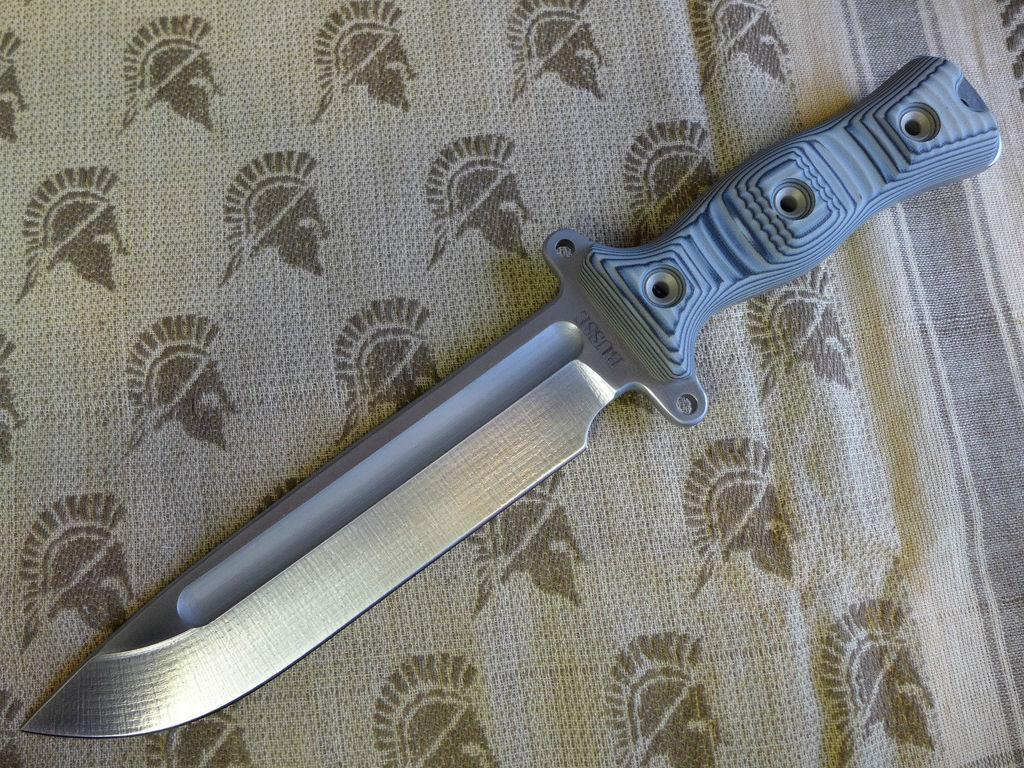What object is present in the image that can be used for cutting? There is a knife in the image. What color is the knife? The knife is grey in color. On what surface is the knife placed? The knife is on a cloth. What colors are present on the cloth? The cloth is cream and brown in color. What type of patch can be seen on the knife in the image? There is no patch present on the knife in the image. What form does the journey take in the image? There is no journey depicted in the image; it only shows a knife on a cloth. 